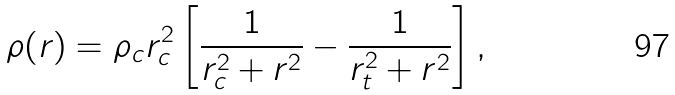Convert formula to latex. <formula><loc_0><loc_0><loc_500><loc_500>\rho ( r ) = \rho _ { c } r _ { c } ^ { 2 } \left [ \frac { 1 } { r _ { c } ^ { 2 } + r ^ { 2 } } - \frac { 1 } { r _ { t } ^ { 2 } + r ^ { 2 } } \right ] ,</formula> 